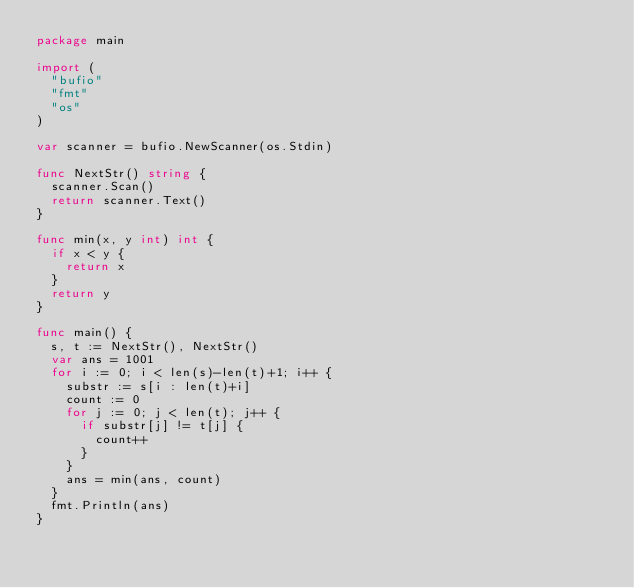<code> <loc_0><loc_0><loc_500><loc_500><_Go_>package main

import (
	"bufio"
	"fmt"
	"os"
)

var scanner = bufio.NewScanner(os.Stdin)

func NextStr() string {
	scanner.Scan()
	return scanner.Text()
}

func min(x, y int) int {
	if x < y {
		return x
	}
	return y
}

func main() {
	s, t := NextStr(), NextStr()
	var ans = 1001
	for i := 0; i < len(s)-len(t)+1; i++ {
		substr := s[i : len(t)+i]
		count := 0
		for j := 0; j < len(t); j++ {
			if substr[j] != t[j] {
				count++
			}
		}
		ans = min(ans, count)
	}
	fmt.Println(ans)
}
</code> 